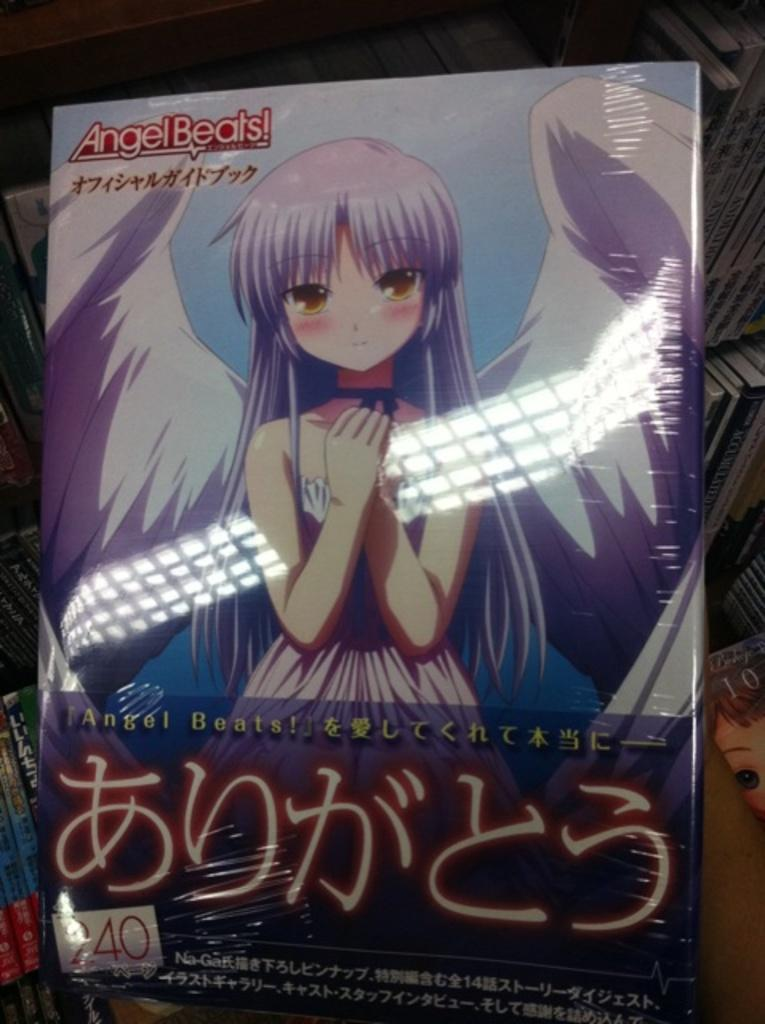What is depicted on the book in the image? There is a cartoon woman picture on the book. What can be seen in the background of the image? The background of the image contains a number of books. What type of wax can be seen melting on the teeth of the cartoon woman in the image? There is no wax or teeth present in the image; it features a cartoon woman picture on a book. What kind of bottle is visible on the shelf behind the books in the image? There is no bottle visible in the image; it only shows a book with a cartoon woman picture and a background of other books. 